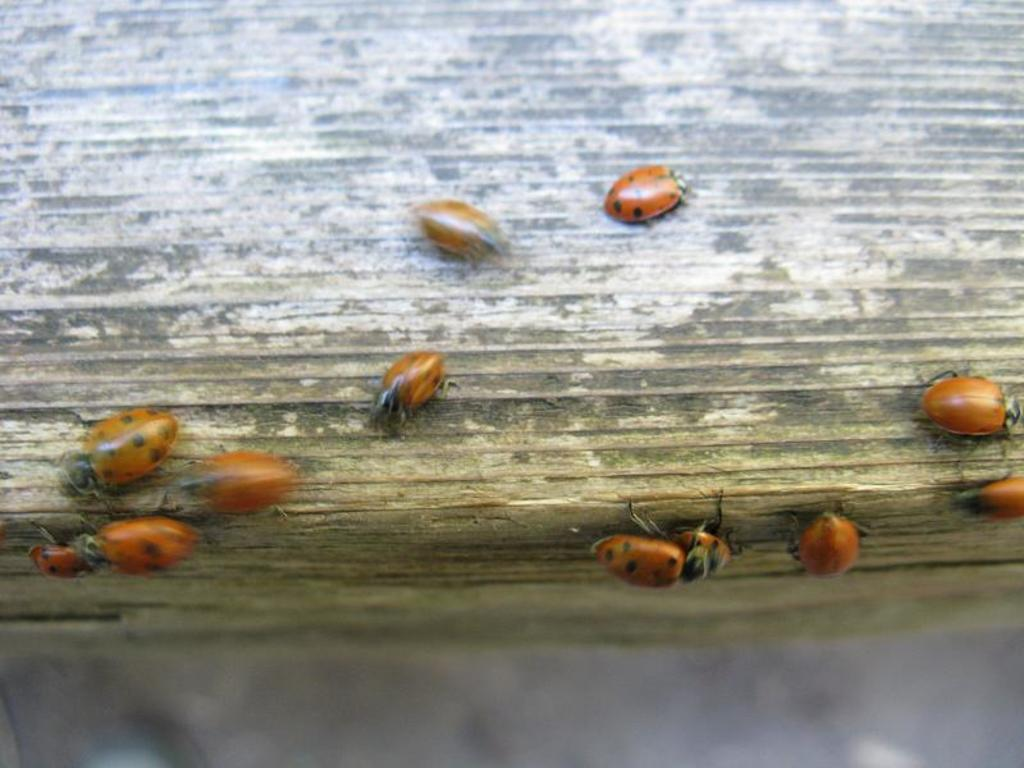What is the main object in the image? There is a white and brown object in the image. What can be seen on the object? There are brown insects on the object. Can you describe the clarity of the image? The image may be slightly blurry. What type of duck can be seen in the image? There is no duck present in the image; it features a white and brown object with brown insects on it. Can you tell me how many church bells are ringing in the image? There is no church or church bells present in the image. 